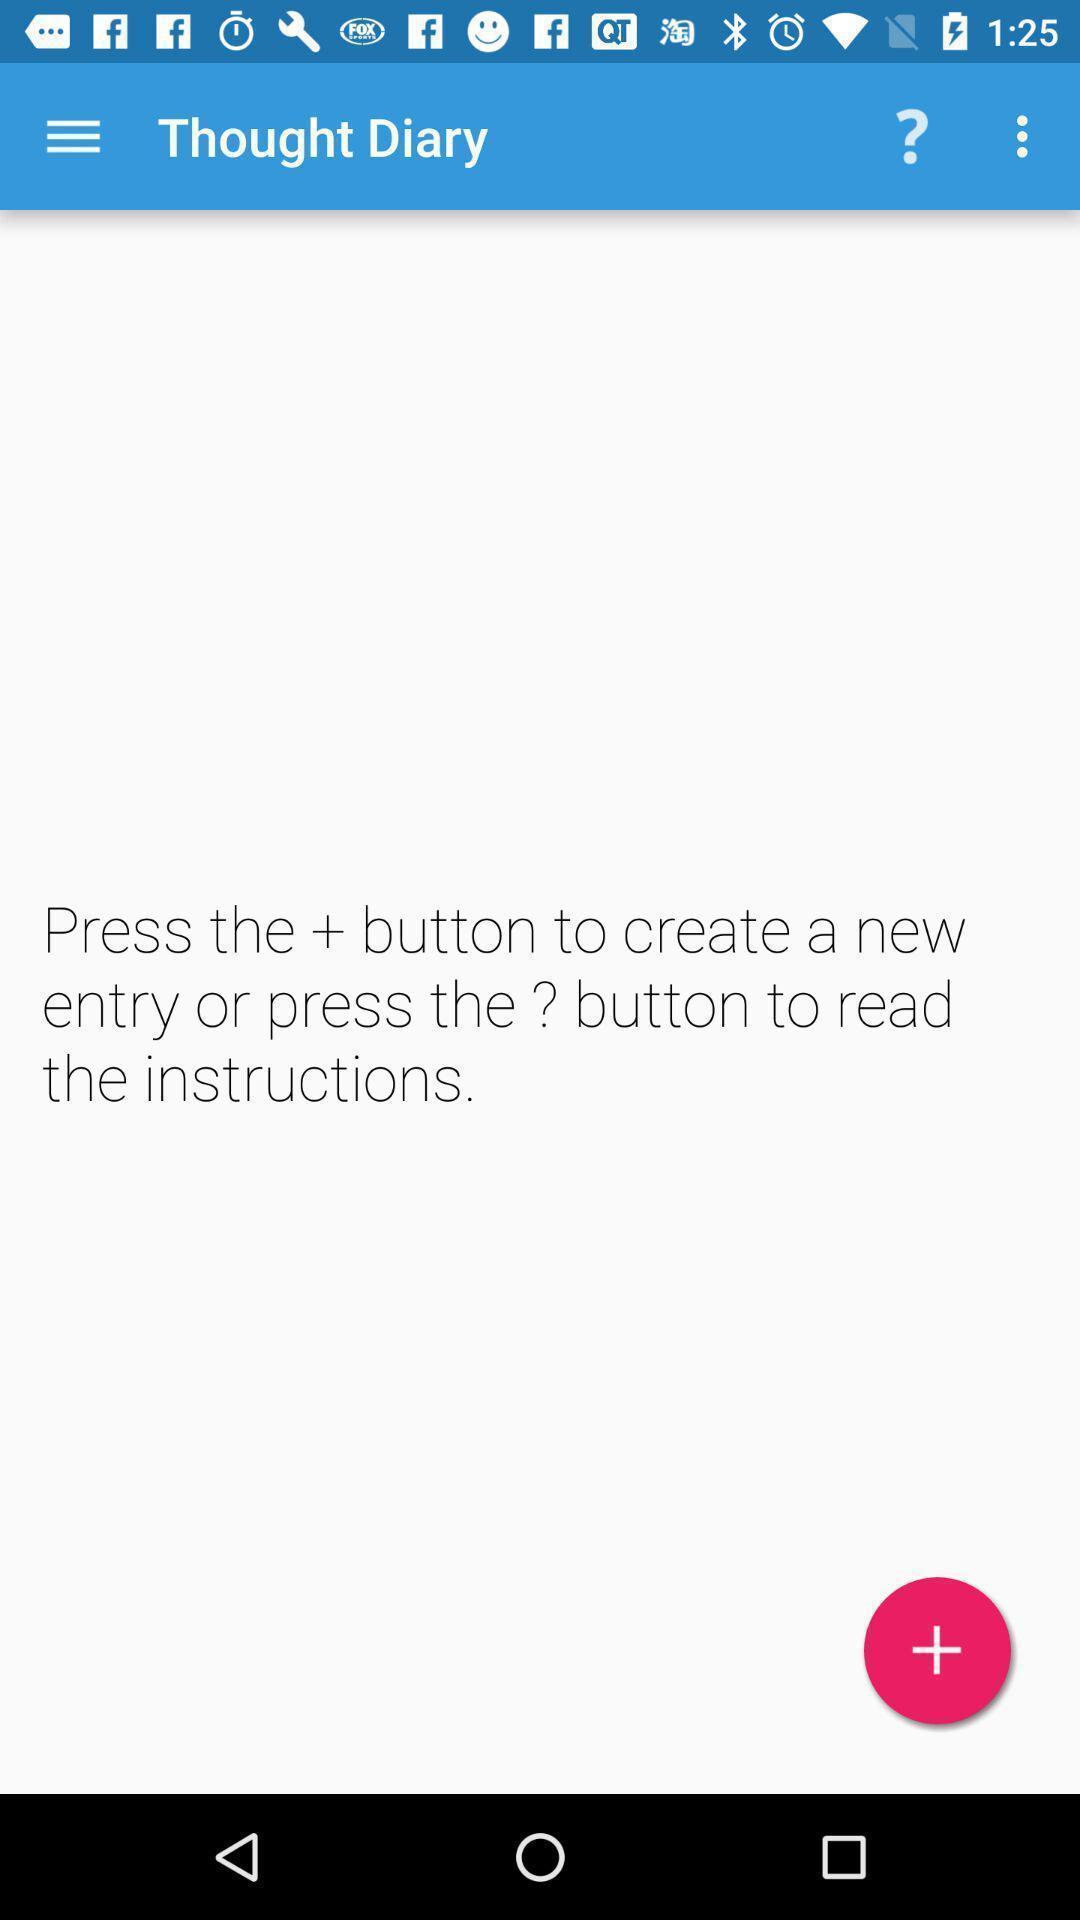Provide a description of this screenshot. Screen shows thought details in diary app with other options. 